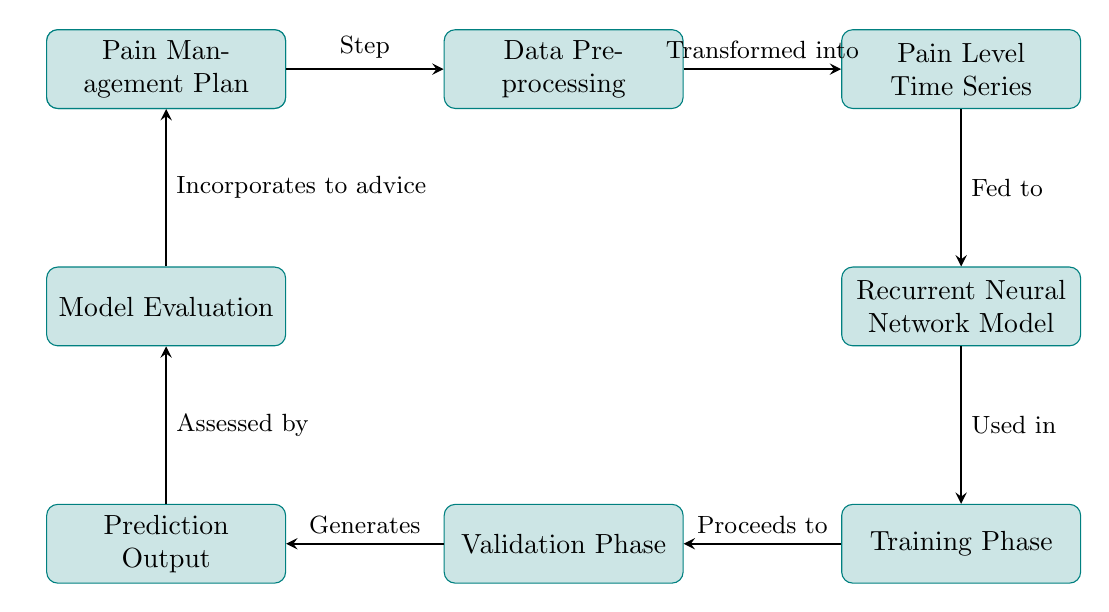What is the first step in the diagram? The first step shown is "Patient Data," which is the starting point for processing.
Answer: Patient Data How many processing steps are represented in the diagram? Counting all the boxes labeled as processes, there are a total of 7 processing steps from start to finish.
Answer: 7 What does the "Prediction Output" generate? The "Validation Phase" directly leads to generating the "Prediction Output," indicating the result of the model's predictions.
Answer: Generates What is used in the "Training Phase"? The "Recurrent Neural Network Model" is used during the "Training Phase" as per the connection in the diagram.
Answer: Recurrent Neural Network Model Which phase incorporates the assessment into the "Pain Management Plan"? The "Model Evaluation" phase incorporates the results to provide advice in the "Pain Management Plan."
Answer: Model Evaluation What transformation occurs after “Data Preprocessing”? The "Data Preprocessing" transforms data into a "Pain Level Time Series," indicating the format change after preprocessing.
Answer: Transformed into Which step does the "Recurrent Neural Network Model" feed into? The "Recurrent Neural Network Model" feeds into the "Training Phase," reflecting that the model's design is utilized during the training.
Answer: Training Phase How is the "Pain Level Time Series" treated in this diagram? The "Pain Level Time Series" is noted as being fed to the "Recurrent Neural Network Model," emphasizing its role as input data.
Answer: Fed to Which component is evaluated in the "Model Evaluation"? The "Prediction Output" is assessed in the "Model Evaluation," which indicates that predictions are reviewed to determine their effectiveness.
Answer: Assessed by 